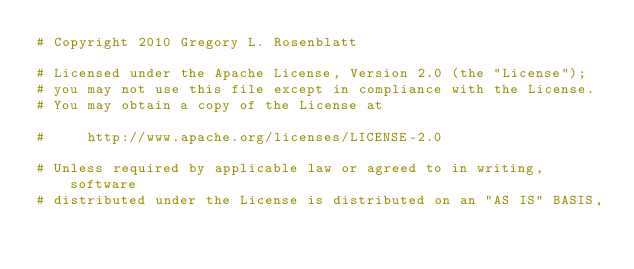<code> <loc_0><loc_0><loc_500><loc_500><_Python_># Copyright 2010 Gregory L. Rosenblatt

# Licensed under the Apache License, Version 2.0 (the "License");
# you may not use this file except in compliance with the License.
# You may obtain a copy of the License at

#     http://www.apache.org/licenses/LICENSE-2.0

# Unless required by applicable law or agreed to in writing, software
# distributed under the License is distributed on an "AS IS" BASIS,</code> 